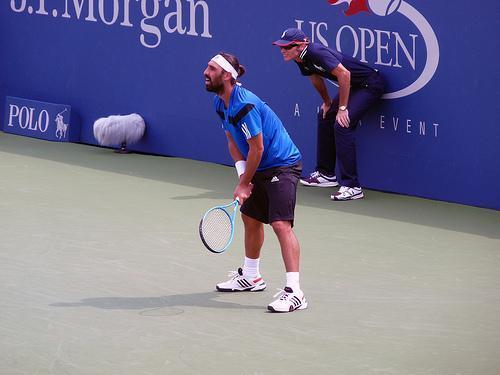How many people are in the picture?
Give a very brief answer. 2. How many players are in the picture?
Give a very brief answer. 1. 